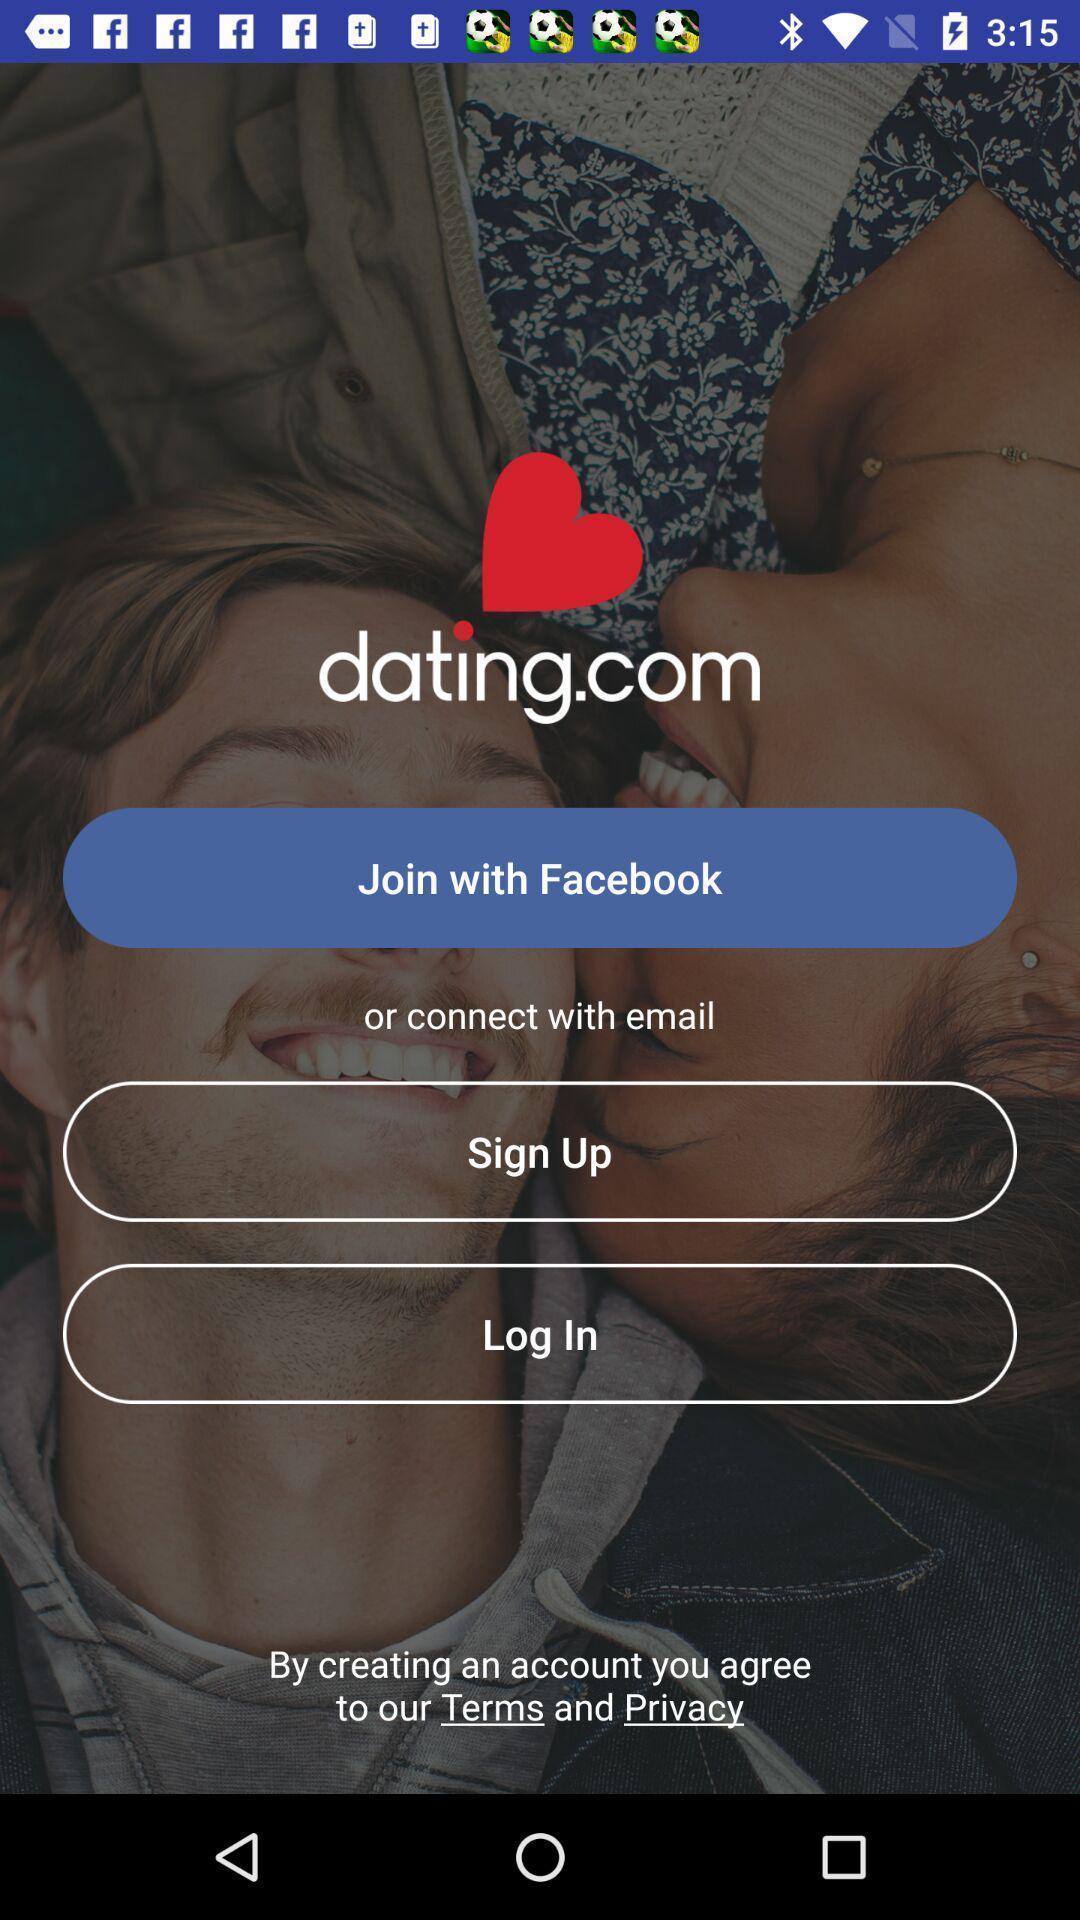What is the overall content of this screenshot? Welcome page. 